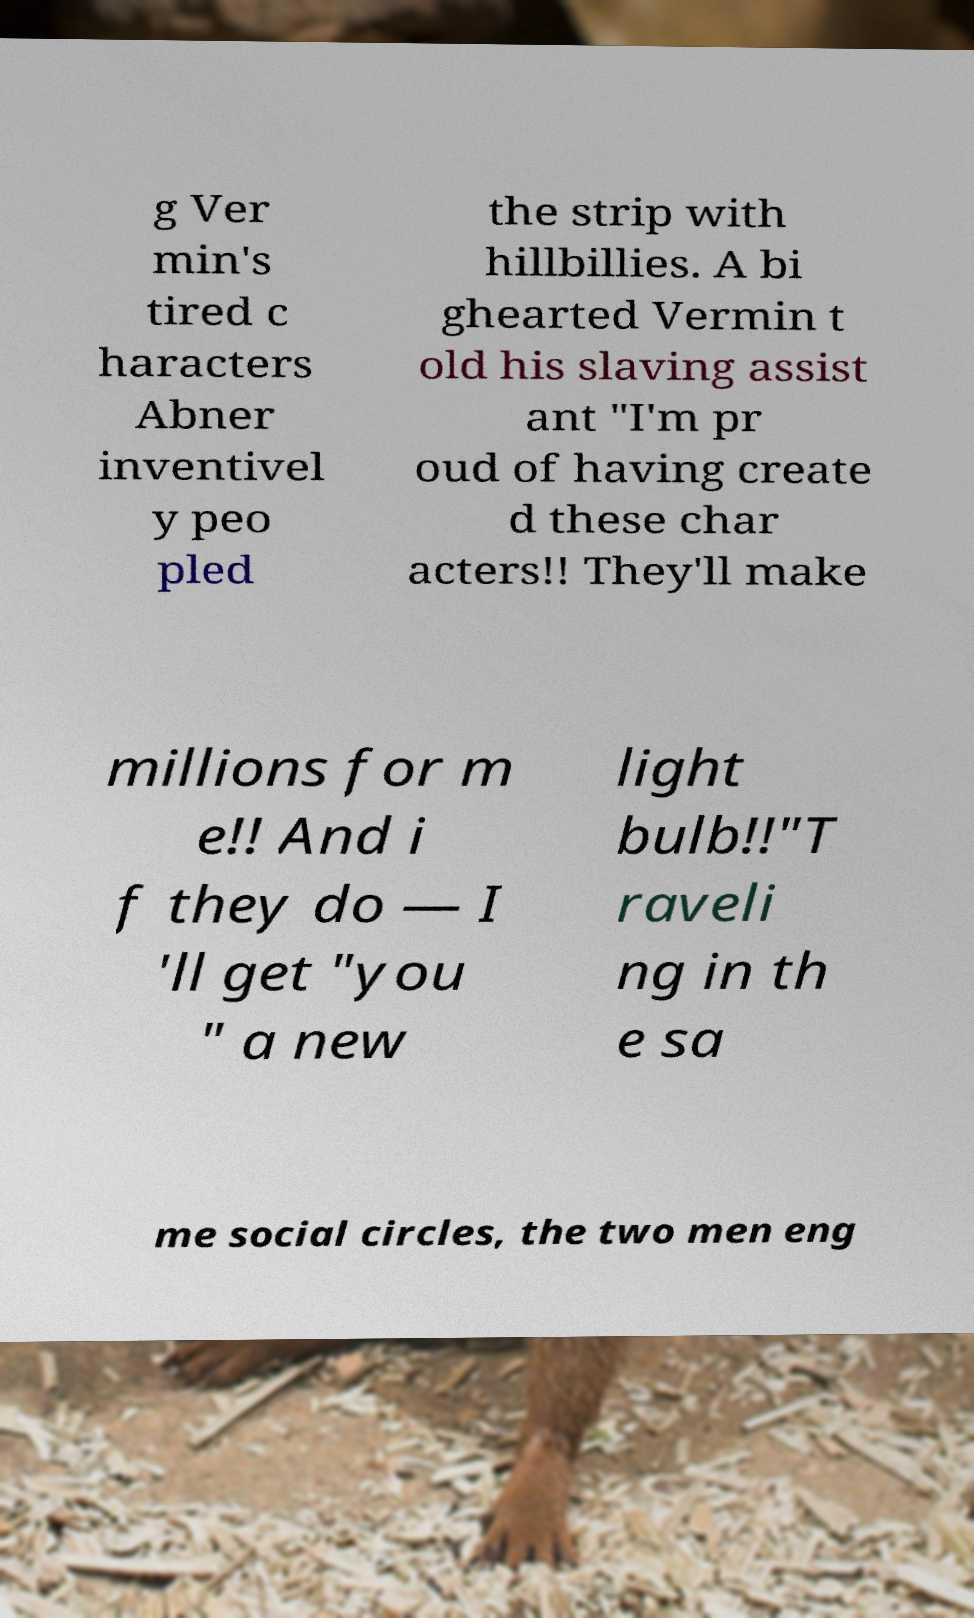Can you read and provide the text displayed in the image?This photo seems to have some interesting text. Can you extract and type it out for me? g Ver min's tired c haracters Abner inventivel y peo pled the strip with hillbillies. A bi ghearted Vermin t old his slaving assist ant "I'm pr oud of having create d these char acters!! They'll make millions for m e!! And i f they do — I 'll get "you " a new light bulb!!"T raveli ng in th e sa me social circles, the two men eng 